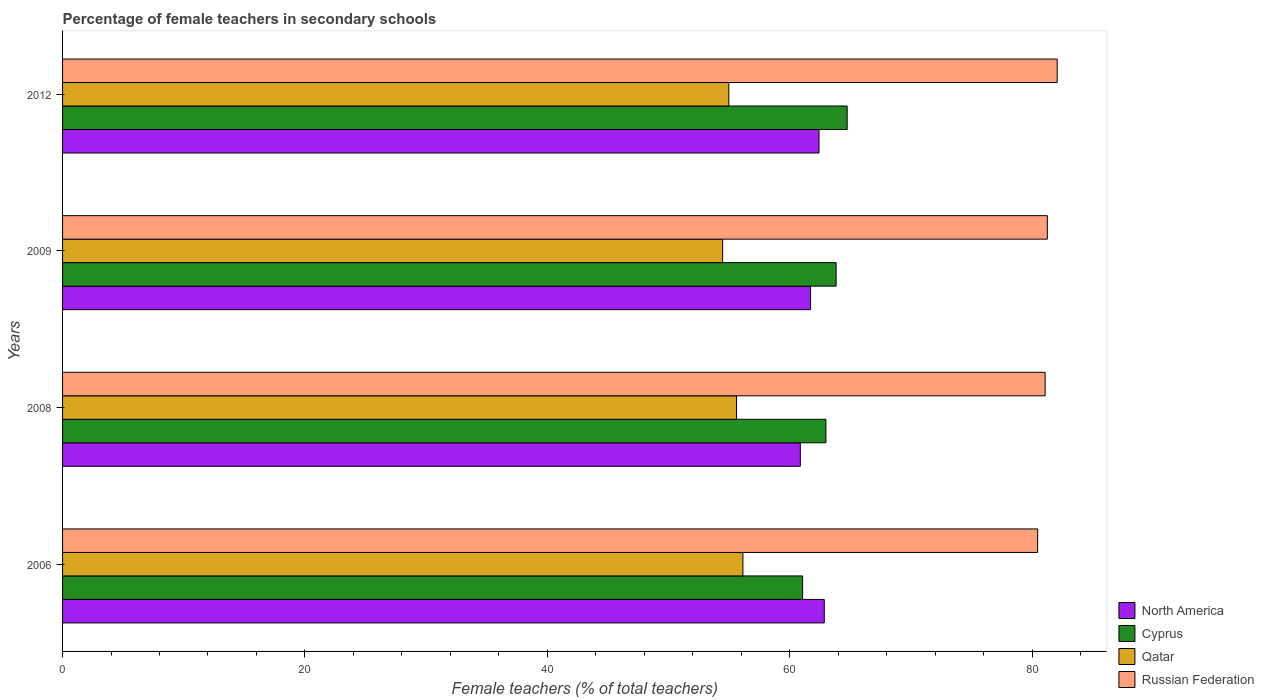How many groups of bars are there?
Make the answer very short. 4. What is the label of the 2nd group of bars from the top?
Ensure brevity in your answer.  2009. What is the percentage of female teachers in Cyprus in 2009?
Offer a terse response. 63.84. Across all years, what is the maximum percentage of female teachers in Qatar?
Make the answer very short. 56.15. Across all years, what is the minimum percentage of female teachers in Russian Federation?
Keep it short and to the point. 80.47. In which year was the percentage of female teachers in Qatar minimum?
Make the answer very short. 2009. What is the total percentage of female teachers in North America in the graph?
Provide a short and direct response. 247.89. What is the difference between the percentage of female teachers in Cyprus in 2006 and that in 2008?
Your response must be concise. -1.92. What is the difference between the percentage of female teachers in Cyprus in 2006 and the percentage of female teachers in Russian Federation in 2008?
Offer a terse response. -20.01. What is the average percentage of female teachers in Russian Federation per year?
Your response must be concise. 81.22. In the year 2009, what is the difference between the percentage of female teachers in Cyprus and percentage of female teachers in Russian Federation?
Give a very brief answer. -17.43. In how many years, is the percentage of female teachers in North America greater than 28 %?
Provide a succinct answer. 4. What is the ratio of the percentage of female teachers in Cyprus in 2006 to that in 2009?
Offer a very short reply. 0.96. What is the difference between the highest and the second highest percentage of female teachers in Qatar?
Ensure brevity in your answer.  0.53. What is the difference between the highest and the lowest percentage of female teachers in Russian Federation?
Provide a succinct answer. 1.61. In how many years, is the percentage of female teachers in Cyprus greater than the average percentage of female teachers in Cyprus taken over all years?
Give a very brief answer. 2. What does the 4th bar from the top in 2009 represents?
Give a very brief answer. North America. What does the 3rd bar from the bottom in 2009 represents?
Make the answer very short. Qatar. Is it the case that in every year, the sum of the percentage of female teachers in Cyprus and percentage of female teachers in Qatar is greater than the percentage of female teachers in Russian Federation?
Give a very brief answer. Yes. How many bars are there?
Provide a short and direct response. 16. Are all the bars in the graph horizontal?
Give a very brief answer. Yes. What is the difference between two consecutive major ticks on the X-axis?
Your answer should be compact. 20. Does the graph contain grids?
Your answer should be compact. No. Where does the legend appear in the graph?
Ensure brevity in your answer.  Bottom right. How many legend labels are there?
Provide a short and direct response. 4. What is the title of the graph?
Make the answer very short. Percentage of female teachers in secondary schools. What is the label or title of the X-axis?
Ensure brevity in your answer.  Female teachers (% of total teachers). What is the label or title of the Y-axis?
Your answer should be compact. Years. What is the Female teachers (% of total teachers) of North America in 2006?
Your answer should be very brief. 62.86. What is the Female teachers (% of total teachers) of Cyprus in 2006?
Your answer should be compact. 61.07. What is the Female teachers (% of total teachers) in Qatar in 2006?
Provide a short and direct response. 56.15. What is the Female teachers (% of total teachers) of Russian Federation in 2006?
Offer a very short reply. 80.47. What is the Female teachers (% of total teachers) in North America in 2008?
Provide a short and direct response. 60.88. What is the Female teachers (% of total teachers) in Cyprus in 2008?
Make the answer very short. 62.99. What is the Female teachers (% of total teachers) in Qatar in 2008?
Give a very brief answer. 55.62. What is the Female teachers (% of total teachers) of Russian Federation in 2008?
Provide a succinct answer. 81.08. What is the Female teachers (% of total teachers) in North America in 2009?
Give a very brief answer. 61.73. What is the Female teachers (% of total teachers) in Cyprus in 2009?
Your answer should be very brief. 63.84. What is the Female teachers (% of total teachers) in Qatar in 2009?
Your response must be concise. 54.47. What is the Female teachers (% of total teachers) in Russian Federation in 2009?
Offer a terse response. 81.27. What is the Female teachers (% of total teachers) of North America in 2012?
Give a very brief answer. 62.43. What is the Female teachers (% of total teachers) in Cyprus in 2012?
Make the answer very short. 64.75. What is the Female teachers (% of total teachers) of Qatar in 2012?
Offer a very short reply. 54.98. What is the Female teachers (% of total teachers) in Russian Federation in 2012?
Make the answer very short. 82.08. Across all years, what is the maximum Female teachers (% of total teachers) in North America?
Offer a terse response. 62.86. Across all years, what is the maximum Female teachers (% of total teachers) of Cyprus?
Provide a short and direct response. 64.75. Across all years, what is the maximum Female teachers (% of total teachers) of Qatar?
Ensure brevity in your answer.  56.15. Across all years, what is the maximum Female teachers (% of total teachers) of Russian Federation?
Your response must be concise. 82.08. Across all years, what is the minimum Female teachers (% of total teachers) in North America?
Keep it short and to the point. 60.88. Across all years, what is the minimum Female teachers (% of total teachers) in Cyprus?
Offer a very short reply. 61.07. Across all years, what is the minimum Female teachers (% of total teachers) in Qatar?
Make the answer very short. 54.47. Across all years, what is the minimum Female teachers (% of total teachers) of Russian Federation?
Your answer should be very brief. 80.47. What is the total Female teachers (% of total teachers) in North America in the graph?
Ensure brevity in your answer.  247.89. What is the total Female teachers (% of total teachers) in Cyprus in the graph?
Give a very brief answer. 252.65. What is the total Female teachers (% of total teachers) of Qatar in the graph?
Offer a very short reply. 221.21. What is the total Female teachers (% of total teachers) of Russian Federation in the graph?
Provide a succinct answer. 324.89. What is the difference between the Female teachers (% of total teachers) in North America in 2006 and that in 2008?
Your answer should be very brief. 1.97. What is the difference between the Female teachers (% of total teachers) in Cyprus in 2006 and that in 2008?
Your answer should be very brief. -1.92. What is the difference between the Female teachers (% of total teachers) of Qatar in 2006 and that in 2008?
Offer a very short reply. 0.53. What is the difference between the Female teachers (% of total teachers) in Russian Federation in 2006 and that in 2008?
Keep it short and to the point. -0.62. What is the difference between the Female teachers (% of total teachers) of North America in 2006 and that in 2009?
Keep it short and to the point. 1.13. What is the difference between the Female teachers (% of total teachers) of Cyprus in 2006 and that in 2009?
Offer a terse response. -2.76. What is the difference between the Female teachers (% of total teachers) of Qatar in 2006 and that in 2009?
Ensure brevity in your answer.  1.67. What is the difference between the Female teachers (% of total teachers) in Russian Federation in 2006 and that in 2009?
Offer a very short reply. -0.8. What is the difference between the Female teachers (% of total teachers) of North America in 2006 and that in 2012?
Ensure brevity in your answer.  0.43. What is the difference between the Female teachers (% of total teachers) of Cyprus in 2006 and that in 2012?
Give a very brief answer. -3.68. What is the difference between the Female teachers (% of total teachers) in Qatar in 2006 and that in 2012?
Your answer should be compact. 1.16. What is the difference between the Female teachers (% of total teachers) in Russian Federation in 2006 and that in 2012?
Your answer should be compact. -1.61. What is the difference between the Female teachers (% of total teachers) of North America in 2008 and that in 2009?
Your answer should be very brief. -0.84. What is the difference between the Female teachers (% of total teachers) in Cyprus in 2008 and that in 2009?
Make the answer very short. -0.84. What is the difference between the Female teachers (% of total teachers) of Qatar in 2008 and that in 2009?
Provide a succinct answer. 1.15. What is the difference between the Female teachers (% of total teachers) in Russian Federation in 2008 and that in 2009?
Keep it short and to the point. -0.18. What is the difference between the Female teachers (% of total teachers) of North America in 2008 and that in 2012?
Give a very brief answer. -1.54. What is the difference between the Female teachers (% of total teachers) of Cyprus in 2008 and that in 2012?
Provide a succinct answer. -1.75. What is the difference between the Female teachers (% of total teachers) of Qatar in 2008 and that in 2012?
Give a very brief answer. 0.64. What is the difference between the Female teachers (% of total teachers) in Russian Federation in 2008 and that in 2012?
Make the answer very short. -1. What is the difference between the Female teachers (% of total teachers) of North America in 2009 and that in 2012?
Provide a short and direct response. -0.7. What is the difference between the Female teachers (% of total teachers) in Cyprus in 2009 and that in 2012?
Your answer should be very brief. -0.91. What is the difference between the Female teachers (% of total teachers) of Qatar in 2009 and that in 2012?
Your answer should be very brief. -0.51. What is the difference between the Female teachers (% of total teachers) of Russian Federation in 2009 and that in 2012?
Your answer should be very brief. -0.81. What is the difference between the Female teachers (% of total teachers) in North America in 2006 and the Female teachers (% of total teachers) in Cyprus in 2008?
Ensure brevity in your answer.  -0.14. What is the difference between the Female teachers (% of total teachers) of North America in 2006 and the Female teachers (% of total teachers) of Qatar in 2008?
Make the answer very short. 7.24. What is the difference between the Female teachers (% of total teachers) in North America in 2006 and the Female teachers (% of total teachers) in Russian Federation in 2008?
Your answer should be compact. -18.23. What is the difference between the Female teachers (% of total teachers) of Cyprus in 2006 and the Female teachers (% of total teachers) of Qatar in 2008?
Provide a succinct answer. 5.45. What is the difference between the Female teachers (% of total teachers) of Cyprus in 2006 and the Female teachers (% of total teachers) of Russian Federation in 2008?
Your answer should be very brief. -20.01. What is the difference between the Female teachers (% of total teachers) in Qatar in 2006 and the Female teachers (% of total teachers) in Russian Federation in 2008?
Offer a terse response. -24.94. What is the difference between the Female teachers (% of total teachers) of North America in 2006 and the Female teachers (% of total teachers) of Cyprus in 2009?
Provide a short and direct response. -0.98. What is the difference between the Female teachers (% of total teachers) of North America in 2006 and the Female teachers (% of total teachers) of Qatar in 2009?
Your answer should be very brief. 8.39. What is the difference between the Female teachers (% of total teachers) in North America in 2006 and the Female teachers (% of total teachers) in Russian Federation in 2009?
Your answer should be very brief. -18.41. What is the difference between the Female teachers (% of total teachers) in Cyprus in 2006 and the Female teachers (% of total teachers) in Qatar in 2009?
Provide a short and direct response. 6.6. What is the difference between the Female teachers (% of total teachers) of Cyprus in 2006 and the Female teachers (% of total teachers) of Russian Federation in 2009?
Provide a succinct answer. -20.2. What is the difference between the Female teachers (% of total teachers) in Qatar in 2006 and the Female teachers (% of total teachers) in Russian Federation in 2009?
Keep it short and to the point. -25.12. What is the difference between the Female teachers (% of total teachers) in North America in 2006 and the Female teachers (% of total teachers) in Cyprus in 2012?
Keep it short and to the point. -1.89. What is the difference between the Female teachers (% of total teachers) of North America in 2006 and the Female teachers (% of total teachers) of Qatar in 2012?
Offer a very short reply. 7.88. What is the difference between the Female teachers (% of total teachers) of North America in 2006 and the Female teachers (% of total teachers) of Russian Federation in 2012?
Provide a short and direct response. -19.22. What is the difference between the Female teachers (% of total teachers) in Cyprus in 2006 and the Female teachers (% of total teachers) in Qatar in 2012?
Offer a terse response. 6.09. What is the difference between the Female teachers (% of total teachers) of Cyprus in 2006 and the Female teachers (% of total teachers) of Russian Federation in 2012?
Ensure brevity in your answer.  -21.01. What is the difference between the Female teachers (% of total teachers) in Qatar in 2006 and the Female teachers (% of total teachers) in Russian Federation in 2012?
Provide a succinct answer. -25.93. What is the difference between the Female teachers (% of total teachers) of North America in 2008 and the Female teachers (% of total teachers) of Cyprus in 2009?
Provide a short and direct response. -2.95. What is the difference between the Female teachers (% of total teachers) of North America in 2008 and the Female teachers (% of total teachers) of Qatar in 2009?
Make the answer very short. 6.41. What is the difference between the Female teachers (% of total teachers) in North America in 2008 and the Female teachers (% of total teachers) in Russian Federation in 2009?
Make the answer very short. -20.38. What is the difference between the Female teachers (% of total teachers) of Cyprus in 2008 and the Female teachers (% of total teachers) of Qatar in 2009?
Your answer should be compact. 8.52. What is the difference between the Female teachers (% of total teachers) of Cyprus in 2008 and the Female teachers (% of total teachers) of Russian Federation in 2009?
Give a very brief answer. -18.27. What is the difference between the Female teachers (% of total teachers) of Qatar in 2008 and the Female teachers (% of total teachers) of Russian Federation in 2009?
Make the answer very short. -25.65. What is the difference between the Female teachers (% of total teachers) of North America in 2008 and the Female teachers (% of total teachers) of Cyprus in 2012?
Provide a short and direct response. -3.87. What is the difference between the Female teachers (% of total teachers) of North America in 2008 and the Female teachers (% of total teachers) of Qatar in 2012?
Your answer should be compact. 5.9. What is the difference between the Female teachers (% of total teachers) in North America in 2008 and the Female teachers (% of total teachers) in Russian Federation in 2012?
Provide a short and direct response. -21.2. What is the difference between the Female teachers (% of total teachers) in Cyprus in 2008 and the Female teachers (% of total teachers) in Qatar in 2012?
Your response must be concise. 8.01. What is the difference between the Female teachers (% of total teachers) in Cyprus in 2008 and the Female teachers (% of total teachers) in Russian Federation in 2012?
Your answer should be very brief. -19.08. What is the difference between the Female teachers (% of total teachers) in Qatar in 2008 and the Female teachers (% of total teachers) in Russian Federation in 2012?
Your answer should be compact. -26.46. What is the difference between the Female teachers (% of total teachers) in North America in 2009 and the Female teachers (% of total teachers) in Cyprus in 2012?
Make the answer very short. -3.02. What is the difference between the Female teachers (% of total teachers) in North America in 2009 and the Female teachers (% of total teachers) in Qatar in 2012?
Provide a short and direct response. 6.74. What is the difference between the Female teachers (% of total teachers) of North America in 2009 and the Female teachers (% of total teachers) of Russian Federation in 2012?
Give a very brief answer. -20.35. What is the difference between the Female teachers (% of total teachers) in Cyprus in 2009 and the Female teachers (% of total teachers) in Qatar in 2012?
Your answer should be compact. 8.85. What is the difference between the Female teachers (% of total teachers) of Cyprus in 2009 and the Female teachers (% of total teachers) of Russian Federation in 2012?
Offer a very short reply. -18.24. What is the difference between the Female teachers (% of total teachers) of Qatar in 2009 and the Female teachers (% of total teachers) of Russian Federation in 2012?
Your answer should be compact. -27.61. What is the average Female teachers (% of total teachers) in North America per year?
Offer a terse response. 61.97. What is the average Female teachers (% of total teachers) in Cyprus per year?
Give a very brief answer. 63.16. What is the average Female teachers (% of total teachers) of Qatar per year?
Your answer should be compact. 55.3. What is the average Female teachers (% of total teachers) in Russian Federation per year?
Offer a very short reply. 81.22. In the year 2006, what is the difference between the Female teachers (% of total teachers) in North America and Female teachers (% of total teachers) in Cyprus?
Keep it short and to the point. 1.79. In the year 2006, what is the difference between the Female teachers (% of total teachers) of North America and Female teachers (% of total teachers) of Qatar?
Provide a succinct answer. 6.71. In the year 2006, what is the difference between the Female teachers (% of total teachers) of North America and Female teachers (% of total teachers) of Russian Federation?
Provide a short and direct response. -17.61. In the year 2006, what is the difference between the Female teachers (% of total teachers) of Cyprus and Female teachers (% of total teachers) of Qatar?
Provide a succinct answer. 4.93. In the year 2006, what is the difference between the Female teachers (% of total teachers) of Cyprus and Female teachers (% of total teachers) of Russian Federation?
Make the answer very short. -19.39. In the year 2006, what is the difference between the Female teachers (% of total teachers) of Qatar and Female teachers (% of total teachers) of Russian Federation?
Make the answer very short. -24.32. In the year 2008, what is the difference between the Female teachers (% of total teachers) of North America and Female teachers (% of total teachers) of Cyprus?
Your answer should be very brief. -2.11. In the year 2008, what is the difference between the Female teachers (% of total teachers) in North America and Female teachers (% of total teachers) in Qatar?
Your answer should be very brief. 5.27. In the year 2008, what is the difference between the Female teachers (% of total teachers) of North America and Female teachers (% of total teachers) of Russian Federation?
Offer a very short reply. -20.2. In the year 2008, what is the difference between the Female teachers (% of total teachers) of Cyprus and Female teachers (% of total teachers) of Qatar?
Offer a terse response. 7.38. In the year 2008, what is the difference between the Female teachers (% of total teachers) in Cyprus and Female teachers (% of total teachers) in Russian Federation?
Provide a short and direct response. -18.09. In the year 2008, what is the difference between the Female teachers (% of total teachers) of Qatar and Female teachers (% of total teachers) of Russian Federation?
Keep it short and to the point. -25.47. In the year 2009, what is the difference between the Female teachers (% of total teachers) in North America and Female teachers (% of total teachers) in Cyprus?
Provide a succinct answer. -2.11. In the year 2009, what is the difference between the Female teachers (% of total teachers) in North America and Female teachers (% of total teachers) in Qatar?
Your answer should be very brief. 7.26. In the year 2009, what is the difference between the Female teachers (% of total teachers) in North America and Female teachers (% of total teachers) in Russian Federation?
Make the answer very short. -19.54. In the year 2009, what is the difference between the Female teachers (% of total teachers) of Cyprus and Female teachers (% of total teachers) of Qatar?
Make the answer very short. 9.37. In the year 2009, what is the difference between the Female teachers (% of total teachers) in Cyprus and Female teachers (% of total teachers) in Russian Federation?
Offer a very short reply. -17.43. In the year 2009, what is the difference between the Female teachers (% of total teachers) of Qatar and Female teachers (% of total teachers) of Russian Federation?
Provide a short and direct response. -26.8. In the year 2012, what is the difference between the Female teachers (% of total teachers) in North America and Female teachers (% of total teachers) in Cyprus?
Offer a very short reply. -2.32. In the year 2012, what is the difference between the Female teachers (% of total teachers) of North America and Female teachers (% of total teachers) of Qatar?
Provide a short and direct response. 7.44. In the year 2012, what is the difference between the Female teachers (% of total teachers) of North America and Female teachers (% of total teachers) of Russian Federation?
Provide a succinct answer. -19.65. In the year 2012, what is the difference between the Female teachers (% of total teachers) in Cyprus and Female teachers (% of total teachers) in Qatar?
Your answer should be compact. 9.77. In the year 2012, what is the difference between the Female teachers (% of total teachers) in Cyprus and Female teachers (% of total teachers) in Russian Federation?
Make the answer very short. -17.33. In the year 2012, what is the difference between the Female teachers (% of total teachers) of Qatar and Female teachers (% of total teachers) of Russian Federation?
Provide a short and direct response. -27.1. What is the ratio of the Female teachers (% of total teachers) in North America in 2006 to that in 2008?
Provide a succinct answer. 1.03. What is the ratio of the Female teachers (% of total teachers) in Cyprus in 2006 to that in 2008?
Provide a succinct answer. 0.97. What is the ratio of the Female teachers (% of total teachers) in Qatar in 2006 to that in 2008?
Offer a terse response. 1.01. What is the ratio of the Female teachers (% of total teachers) of Russian Federation in 2006 to that in 2008?
Your answer should be very brief. 0.99. What is the ratio of the Female teachers (% of total teachers) in North America in 2006 to that in 2009?
Your answer should be very brief. 1.02. What is the ratio of the Female teachers (% of total teachers) in Cyprus in 2006 to that in 2009?
Your response must be concise. 0.96. What is the ratio of the Female teachers (% of total teachers) in Qatar in 2006 to that in 2009?
Provide a short and direct response. 1.03. What is the ratio of the Female teachers (% of total teachers) in North America in 2006 to that in 2012?
Ensure brevity in your answer.  1.01. What is the ratio of the Female teachers (% of total teachers) in Cyprus in 2006 to that in 2012?
Offer a terse response. 0.94. What is the ratio of the Female teachers (% of total teachers) of Qatar in 2006 to that in 2012?
Make the answer very short. 1.02. What is the ratio of the Female teachers (% of total teachers) in Russian Federation in 2006 to that in 2012?
Your response must be concise. 0.98. What is the ratio of the Female teachers (% of total teachers) of North America in 2008 to that in 2009?
Offer a very short reply. 0.99. What is the ratio of the Female teachers (% of total teachers) in Cyprus in 2008 to that in 2009?
Offer a very short reply. 0.99. What is the ratio of the Female teachers (% of total teachers) in Qatar in 2008 to that in 2009?
Your answer should be very brief. 1.02. What is the ratio of the Female teachers (% of total teachers) of Russian Federation in 2008 to that in 2009?
Provide a succinct answer. 1. What is the ratio of the Female teachers (% of total teachers) of North America in 2008 to that in 2012?
Make the answer very short. 0.98. What is the ratio of the Female teachers (% of total teachers) of Cyprus in 2008 to that in 2012?
Offer a terse response. 0.97. What is the ratio of the Female teachers (% of total teachers) in Qatar in 2008 to that in 2012?
Keep it short and to the point. 1.01. What is the ratio of the Female teachers (% of total teachers) of Russian Federation in 2008 to that in 2012?
Provide a succinct answer. 0.99. What is the ratio of the Female teachers (% of total teachers) in North America in 2009 to that in 2012?
Offer a terse response. 0.99. What is the ratio of the Female teachers (% of total teachers) in Cyprus in 2009 to that in 2012?
Ensure brevity in your answer.  0.99. What is the ratio of the Female teachers (% of total teachers) of Qatar in 2009 to that in 2012?
Make the answer very short. 0.99. What is the ratio of the Female teachers (% of total teachers) of Russian Federation in 2009 to that in 2012?
Your answer should be compact. 0.99. What is the difference between the highest and the second highest Female teachers (% of total teachers) in North America?
Ensure brevity in your answer.  0.43. What is the difference between the highest and the second highest Female teachers (% of total teachers) in Cyprus?
Your answer should be compact. 0.91. What is the difference between the highest and the second highest Female teachers (% of total teachers) of Qatar?
Offer a very short reply. 0.53. What is the difference between the highest and the second highest Female teachers (% of total teachers) of Russian Federation?
Your answer should be very brief. 0.81. What is the difference between the highest and the lowest Female teachers (% of total teachers) of North America?
Your response must be concise. 1.97. What is the difference between the highest and the lowest Female teachers (% of total teachers) in Cyprus?
Provide a short and direct response. 3.68. What is the difference between the highest and the lowest Female teachers (% of total teachers) in Qatar?
Your response must be concise. 1.67. What is the difference between the highest and the lowest Female teachers (% of total teachers) of Russian Federation?
Provide a succinct answer. 1.61. 